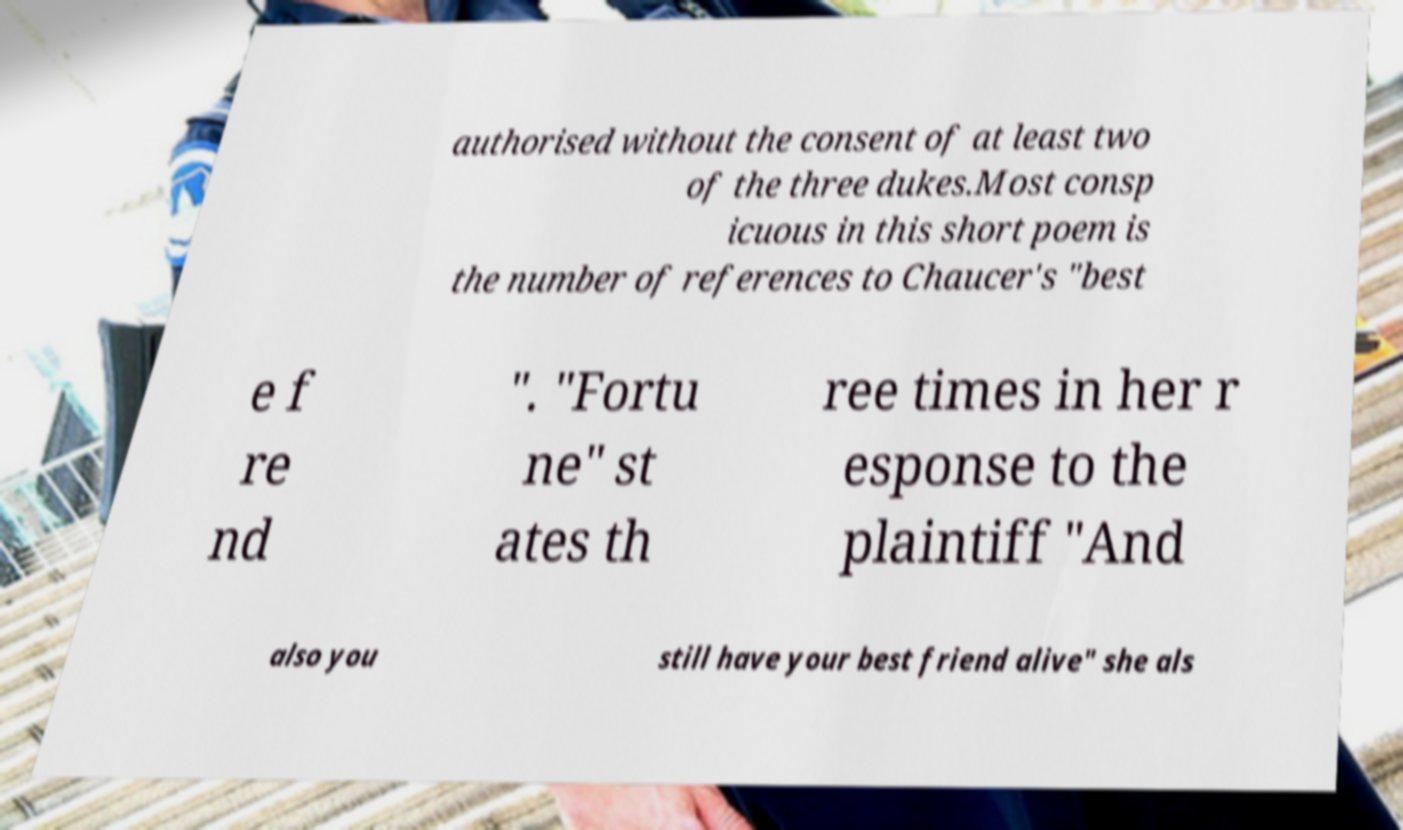Please read and relay the text visible in this image. What does it say? authorised without the consent of at least two of the three dukes.Most consp icuous in this short poem is the number of references to Chaucer's "best e f re nd ". "Fortu ne" st ates th ree times in her r esponse to the plaintiff "And also you still have your best friend alive" she als 